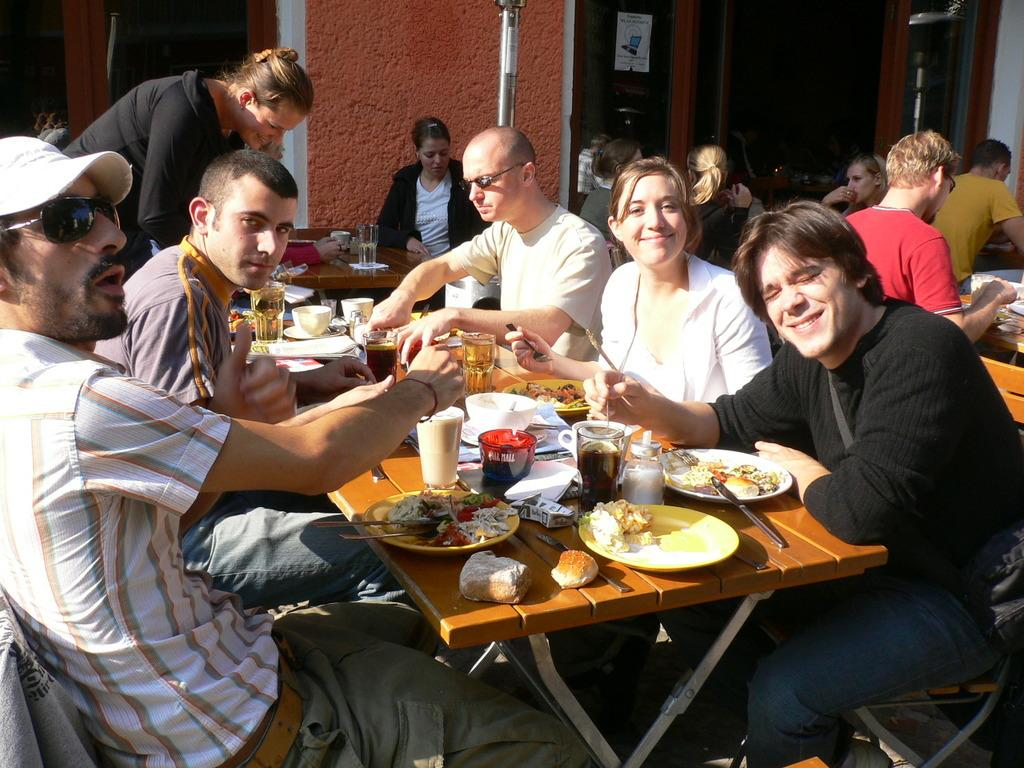What are the people in the image doing? The people in the image are sitting on benches. Are there any standing individuals in the image? Yes, there is a person standing in the image. What items can be seen on the tables in the image? Glasses, plates, food, tissues, and knives are present on the tables in the image. What can be seen in the background of the image? There is a wall and a glass door in the background of the image. What type of sticks are being used to play music in the image? There are no sticks or musical instruments present in the image. Can you tell me where the office is located in the image? There is no office present in the image; it features people sitting and standing around tables with various items. 